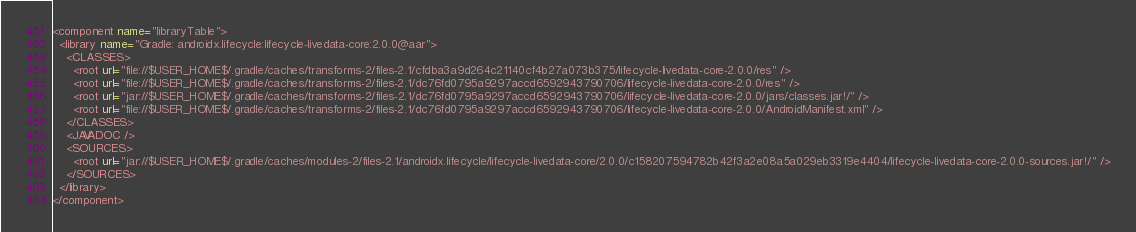Convert code to text. <code><loc_0><loc_0><loc_500><loc_500><_XML_><component name="libraryTable">
  <library name="Gradle: androidx.lifecycle:lifecycle-livedata-core:2.0.0@aar">
    <CLASSES>
      <root url="file://$USER_HOME$/.gradle/caches/transforms-2/files-2.1/cfdba3a9d264c21140cf4b27a073b375/lifecycle-livedata-core-2.0.0/res" />
      <root url="file://$USER_HOME$/.gradle/caches/transforms-2/files-2.1/dc76fd0795a9297accd6592943790706/lifecycle-livedata-core-2.0.0/res" />
      <root url="jar://$USER_HOME$/.gradle/caches/transforms-2/files-2.1/dc76fd0795a9297accd6592943790706/lifecycle-livedata-core-2.0.0/jars/classes.jar!/" />
      <root url="file://$USER_HOME$/.gradle/caches/transforms-2/files-2.1/dc76fd0795a9297accd6592943790706/lifecycle-livedata-core-2.0.0/AndroidManifest.xml" />
    </CLASSES>
    <JAVADOC />
    <SOURCES>
      <root url="jar://$USER_HOME$/.gradle/caches/modules-2/files-2.1/androidx.lifecycle/lifecycle-livedata-core/2.0.0/c158207594782b42f3a2e08a5a029eb3319e4404/lifecycle-livedata-core-2.0.0-sources.jar!/" />
    </SOURCES>
  </library>
</component></code> 